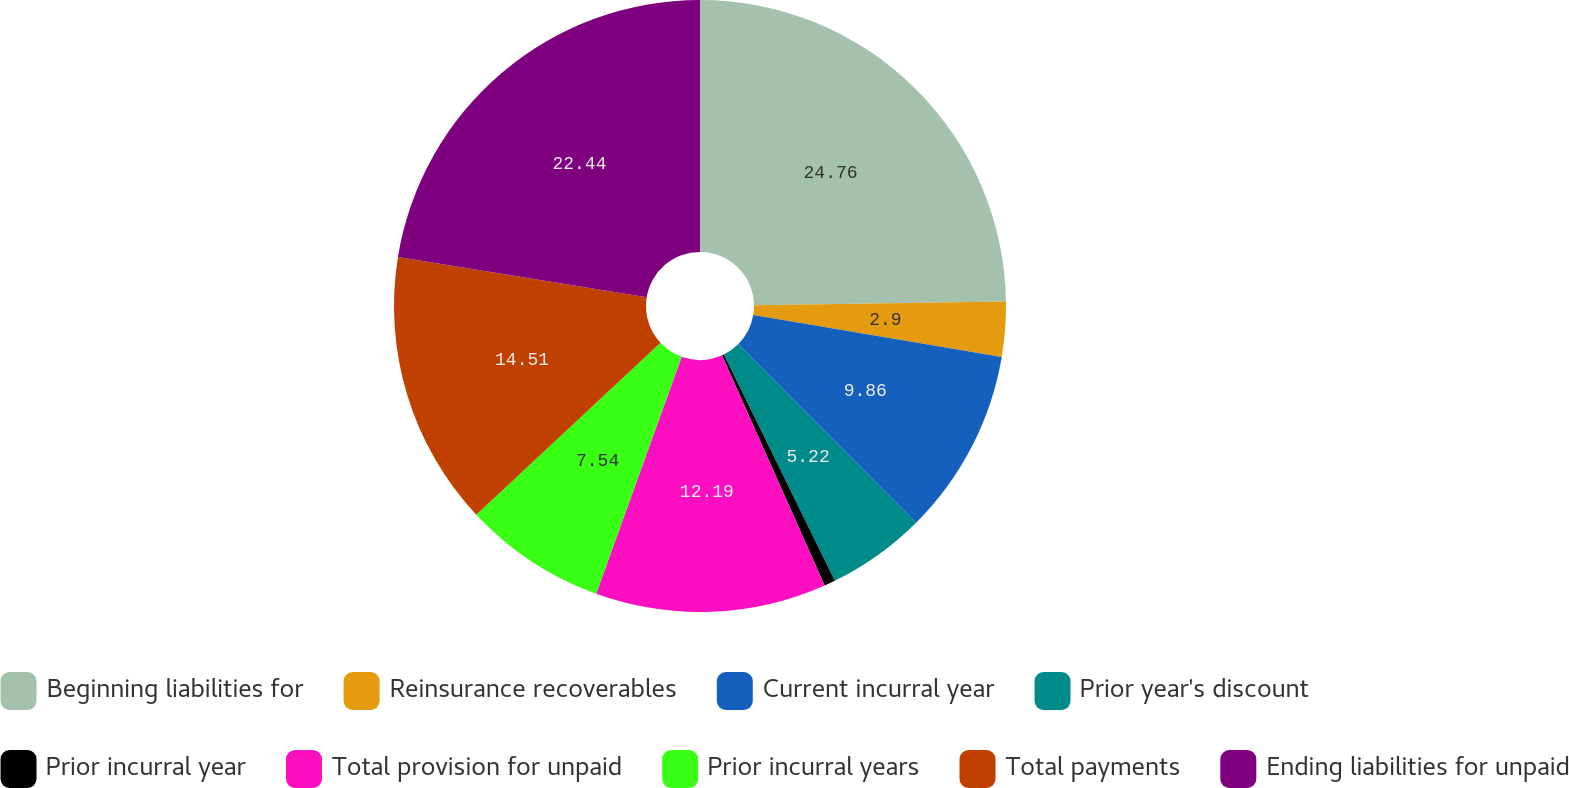Convert chart. <chart><loc_0><loc_0><loc_500><loc_500><pie_chart><fcel>Beginning liabilities for<fcel>Reinsurance recoverables<fcel>Current incurral year<fcel>Prior year's discount<fcel>Prior incurral year<fcel>Total provision for unpaid<fcel>Prior incurral years<fcel>Total payments<fcel>Ending liabilities for unpaid<nl><fcel>24.76%<fcel>2.9%<fcel>9.86%<fcel>5.22%<fcel>0.58%<fcel>12.19%<fcel>7.54%<fcel>14.51%<fcel>22.44%<nl></chart> 